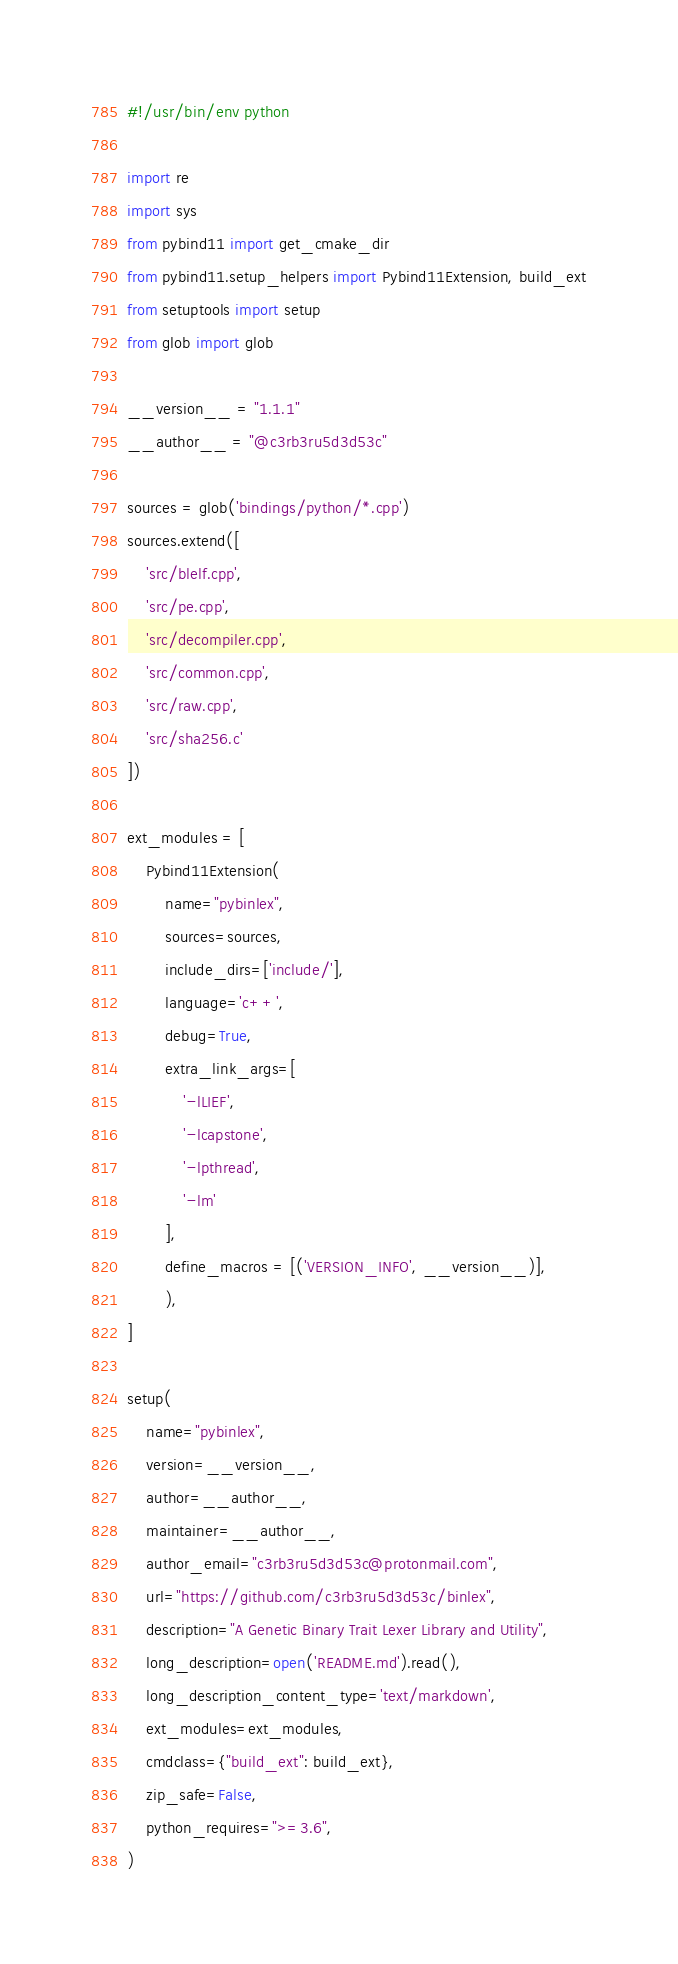Convert code to text. <code><loc_0><loc_0><loc_500><loc_500><_Python_>#!/usr/bin/env python

import re
import sys
from pybind11 import get_cmake_dir
from pybind11.setup_helpers import Pybind11Extension, build_ext
from setuptools import setup
from glob import glob

__version__ = "1.1.1"
__author__ = "@c3rb3ru5d3d53c"

sources = glob('bindings/python/*.cpp')
sources.extend([
    'src/blelf.cpp',
    'src/pe.cpp',
    'src/decompiler.cpp',
    'src/common.cpp',
    'src/raw.cpp',
    'src/sha256.c'
])

ext_modules = [
    Pybind11Extension(
        name="pybinlex",
        sources=sources,
        include_dirs=['include/'],
        language='c++',
        debug=True,
        extra_link_args=[
            '-lLIEF',
            '-lcapstone',
            '-lpthread',
            '-lm'
        ],
        define_macros = [('VERSION_INFO', __version__)],
        ),
]

setup(
    name="pybinlex",
    version=__version__,
    author=__author__,
    maintainer=__author__,
    author_email="c3rb3ru5d3d53c@protonmail.com",
    url="https://github.com/c3rb3ru5d3d53c/binlex",
    description="A Genetic Binary Trait Lexer Library and Utility",
    long_description=open('README.md').read(),
    long_description_content_type='text/markdown',
    ext_modules=ext_modules,
    cmdclass={"build_ext": build_ext},
    zip_safe=False,
    python_requires=">=3.6",
)</code> 